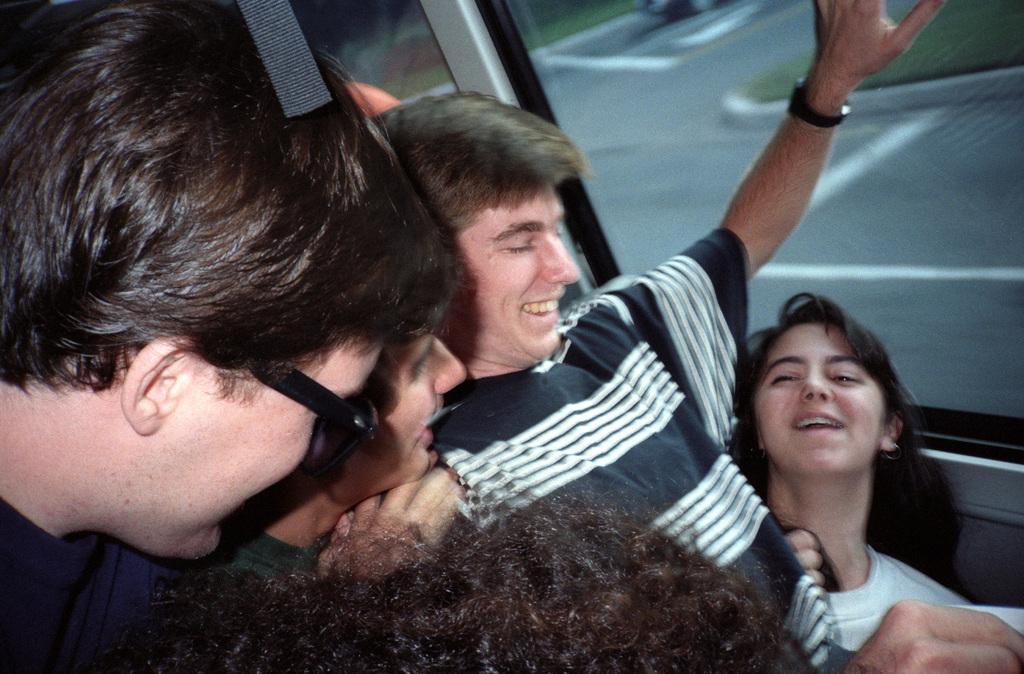In one or two sentences, can you explain what this image depicts? In this image there are some persons in the bottom of this image. There is a glass window on the right side of this image. 